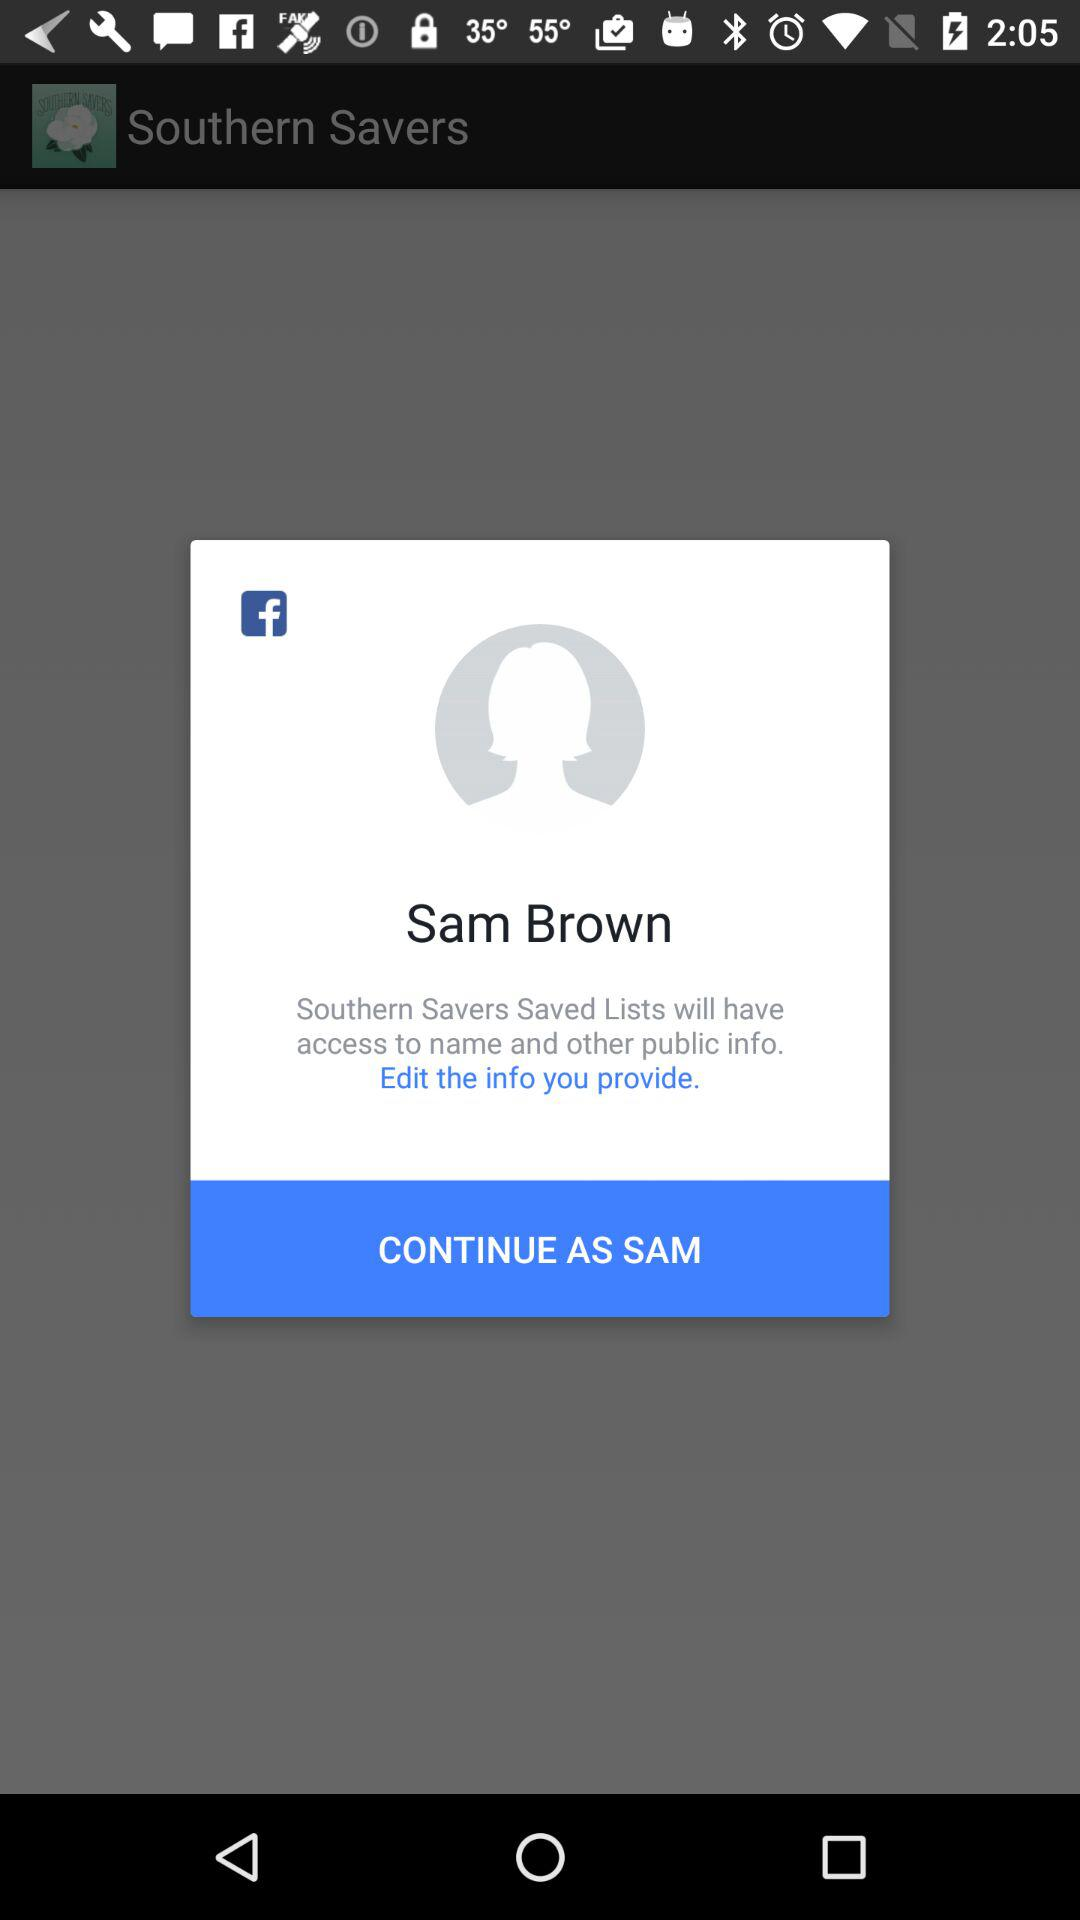What is the user name to continue the profile? The user name is Sam Brown. 